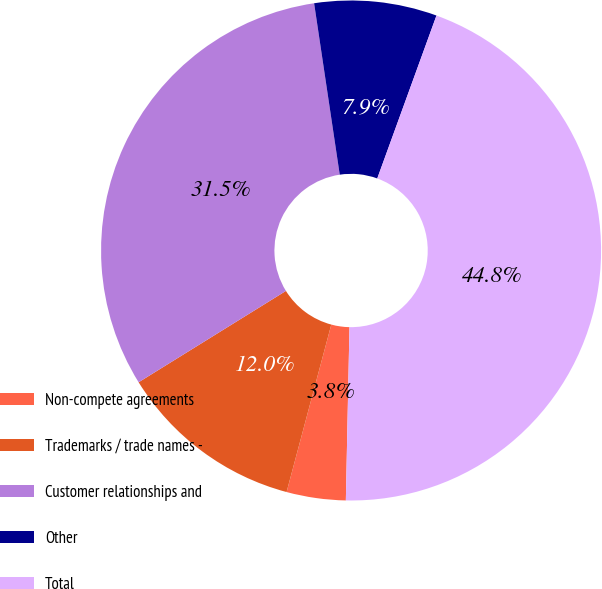<chart> <loc_0><loc_0><loc_500><loc_500><pie_chart><fcel>Non-compete agreements<fcel>Trademarks / trade names -<fcel>Customer relationships and<fcel>Other<fcel>Total<nl><fcel>3.82%<fcel>12.01%<fcel>31.47%<fcel>7.91%<fcel>44.78%<nl></chart> 